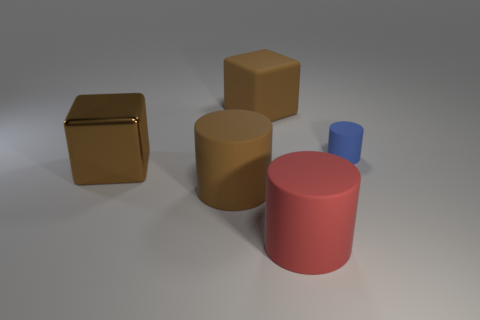Add 4 yellow shiny cubes. How many objects exist? 9 Subtract all cubes. How many objects are left? 3 Add 1 small red cylinders. How many small red cylinders exist? 1 Subtract 0 gray cubes. How many objects are left? 5 Subtract all large brown objects. Subtract all large brown metallic objects. How many objects are left? 1 Add 1 blue things. How many blue things are left? 2 